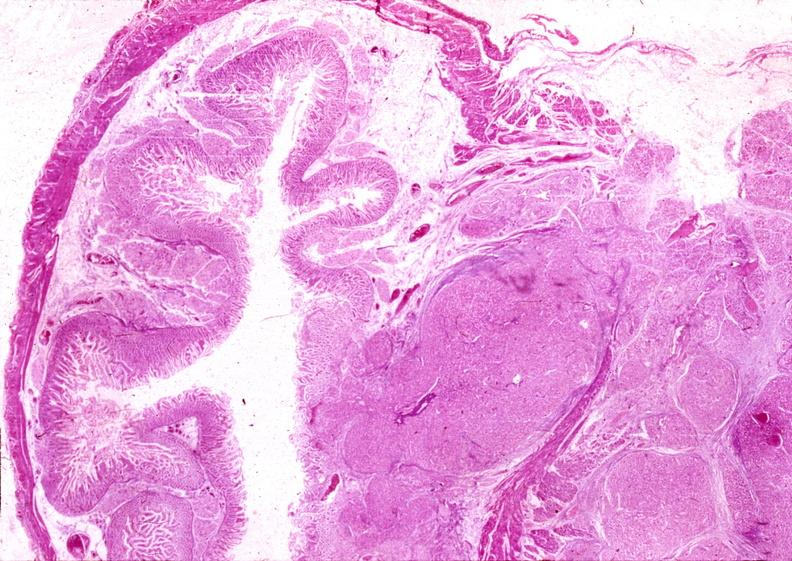what is present?
Answer the question using a single word or phrase. Pancreas 